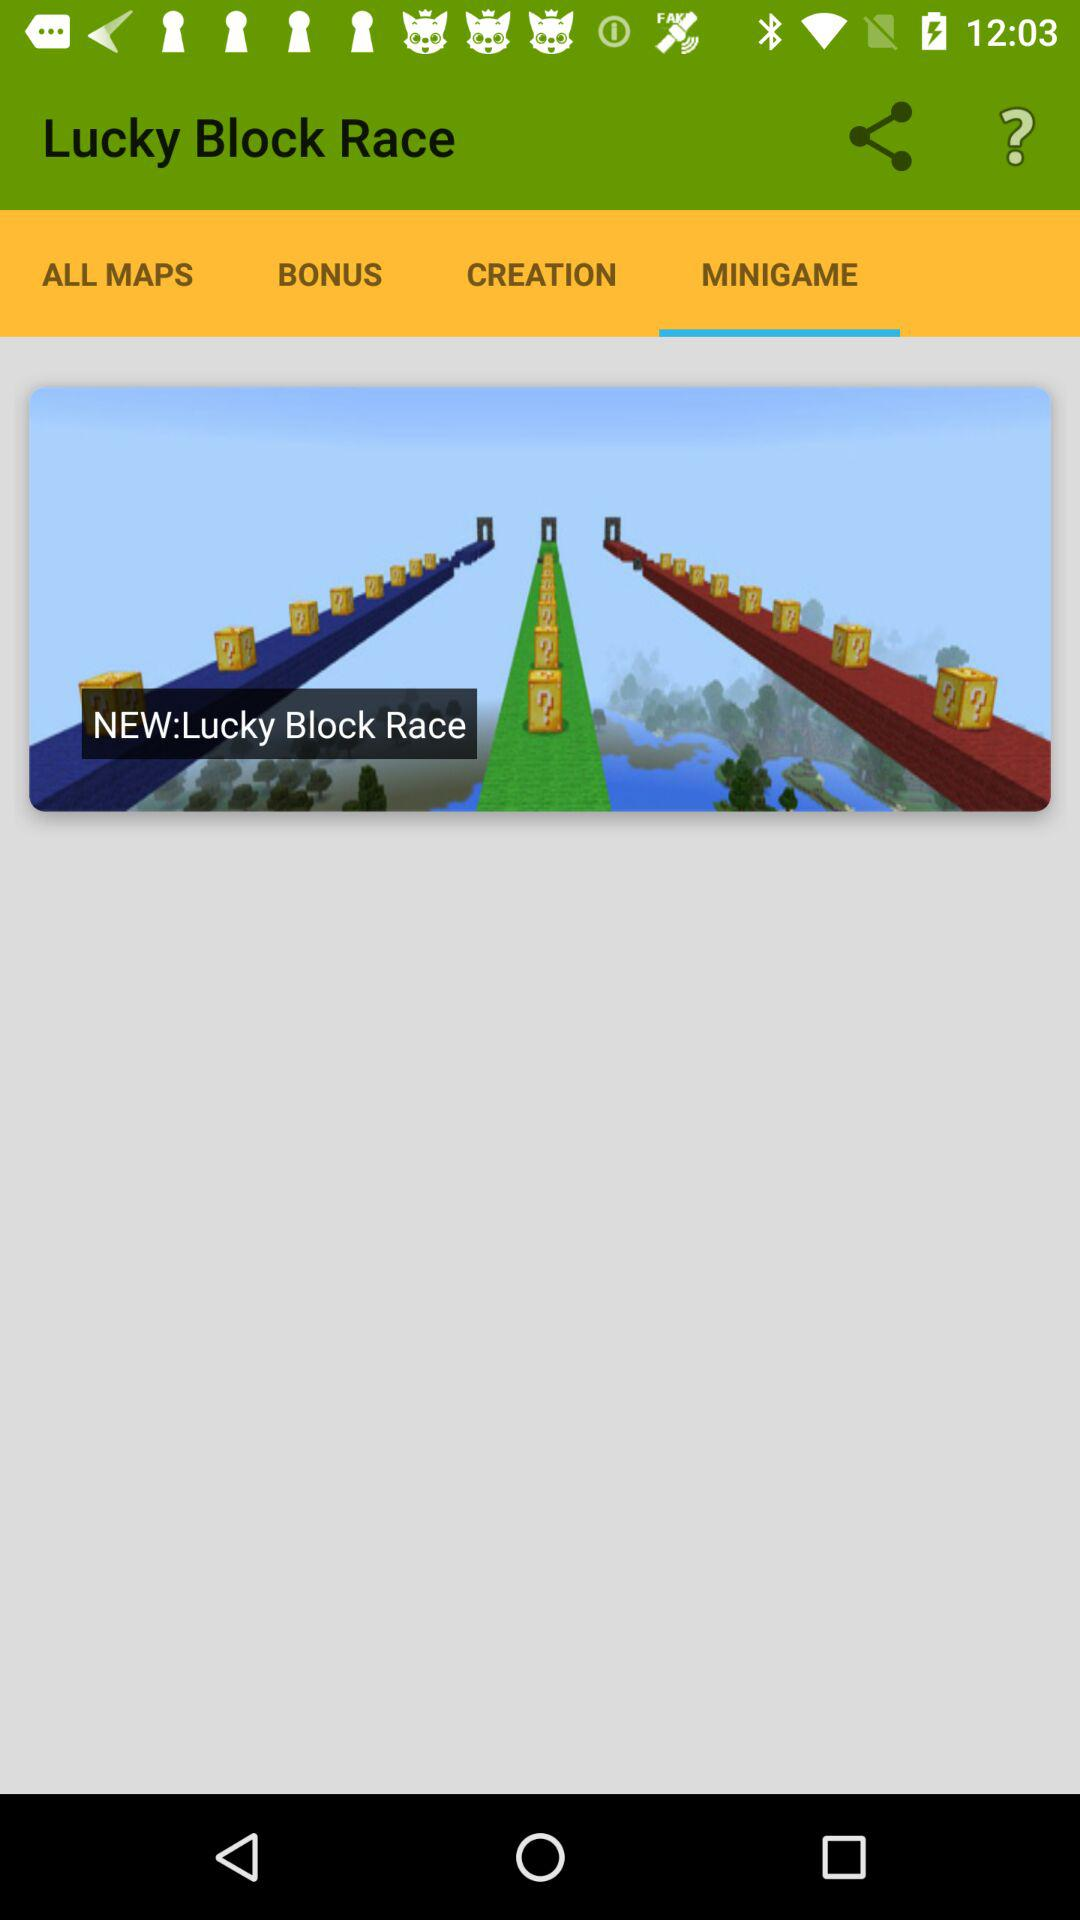What tab is selected? The selected tab is "MINIGAME". 